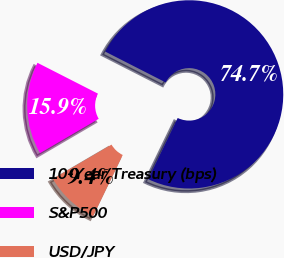<chart> <loc_0><loc_0><loc_500><loc_500><pie_chart><fcel>10-Year Treasury (bps)<fcel>S&P500<fcel>USD/JPY<nl><fcel>74.67%<fcel>15.93%<fcel>9.4%<nl></chart> 